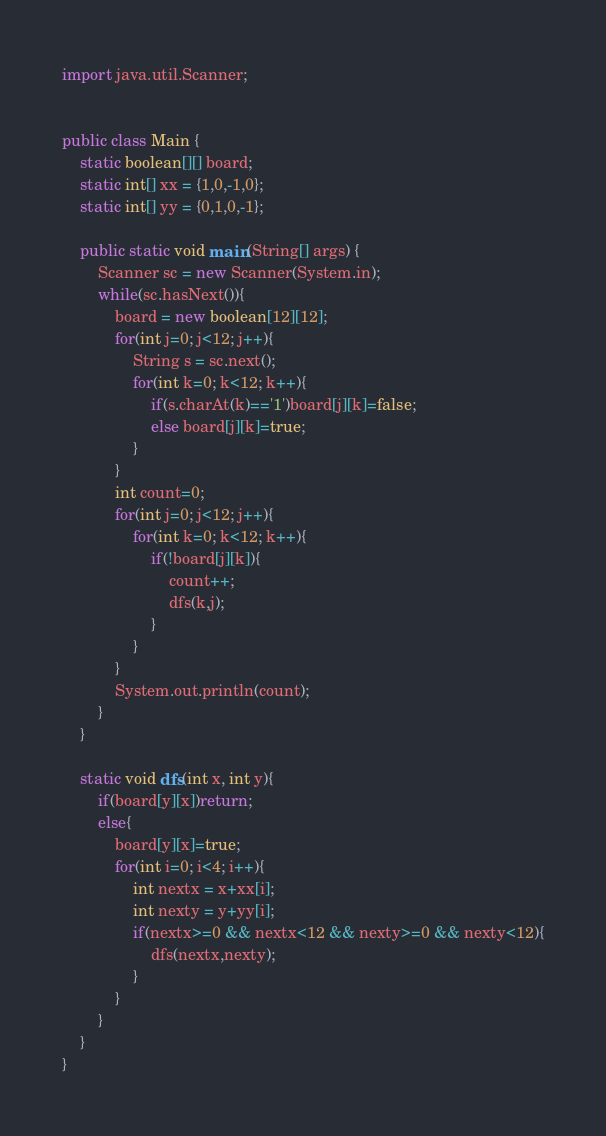Convert code to text. <code><loc_0><loc_0><loc_500><loc_500><_Java_>import java.util.Scanner;


public class Main {
	static boolean[][] board;
	static int[] xx = {1,0,-1,0};
	static int[] yy = {0,1,0,-1};
	
	public static void main(String[] args) {
		Scanner sc = new Scanner(System.in);
		while(sc.hasNext()){
			board = new boolean[12][12];
			for(int j=0; j<12; j++){
				String s = sc.next();
				for(int k=0; k<12; k++){
					if(s.charAt(k)=='1')board[j][k]=false;
					else board[j][k]=true;
				}
			}
			int count=0;
			for(int j=0; j<12; j++){
				for(int k=0; k<12; k++){
					if(!board[j][k]){
						count++;
						dfs(k,j);
					}
				}
			}
			System.out.println(count);
		}
	}
	
	static void dfs(int x, int y){
		if(board[y][x])return;
		else{
			board[y][x]=true;
			for(int i=0; i<4; i++){
				int nextx = x+xx[i];
				int nexty = y+yy[i];
				if(nextx>=0 && nextx<12 && nexty>=0 && nexty<12){
					dfs(nextx,nexty);
				}
			}
		}
	}
}</code> 